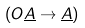<formula> <loc_0><loc_0><loc_500><loc_500>( O \underline { A } \rightarrow \underline { A } )</formula> 